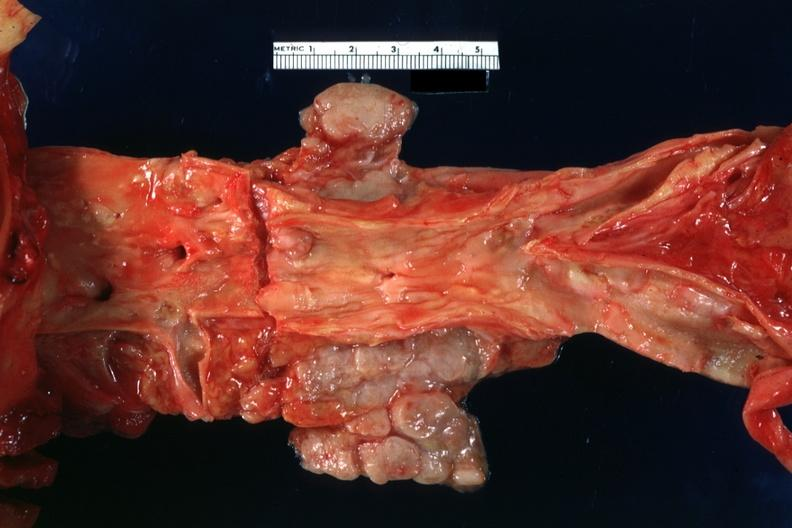what is present?
Answer the question using a single word or phrase. Lymph node 